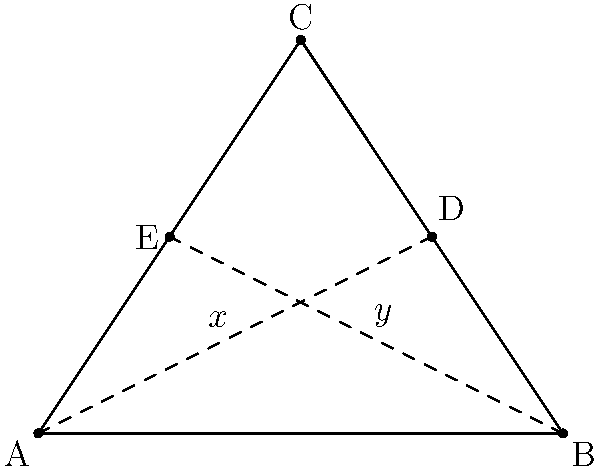In the geometric pattern of a Venetian Bauta mask, we often see triangular designs. Consider the triangle ABC in the diagram, where AD and BE are medians. If the length of AD is $x$ and the length of BE is $y$, what is the ratio of $x$ to $y$? Let's approach this step-by-step:

1) In any triangle, a median divides the opposite side into two equal parts. So, D is the midpoint of BC, and E is the midpoint of AC.

2) We know from the properties of medians that:
   $AD = \frac{2}{3}m$, where m is the length of median AD
   $BE = \frac{2}{3}n$, where n is the length of median BE

3) Now, let's recall the formula for the length of a median:
   For a triangle with sides a, b, and c, the median to side a is:
   $m_a = \frac{1}{2}\sqrt{2b^2 + 2c^2 - a^2}$

4) In our case:
   $x = \frac{2}{3} \cdot \frac{1}{2}\sqrt{2AB^2 + 2AC^2 - BC^2}$
   $y = \frac{2}{3} \cdot \frac{1}{2}\sqrt{2AC^2 + 2BC^2 - AB^2}$

5) The ratio $\frac{x}{y}$ will be:
   $\frac{x}{y} = \frac{\sqrt{2AB^2 + 2AC^2 - BC^2}}{\sqrt{2AC^2 + 2BC^2 - AB^2}}$

6) This ratio depends on the specific dimensions of the triangle. However, for any triangle, this ratio will always be between $\frac{\sqrt{3}}{2}$ and $\frac{2}{\sqrt{3}}$.

7) In the special case of an equilateral triangle, where $AB = BC = AC$, the ratio would simplify to 1, meaning $x = y$.
Answer: $\frac{\sqrt{2AB^2 + 2AC^2 - BC^2}}{\sqrt{2AC^2 + 2BC^2 - AB^2}}$ 